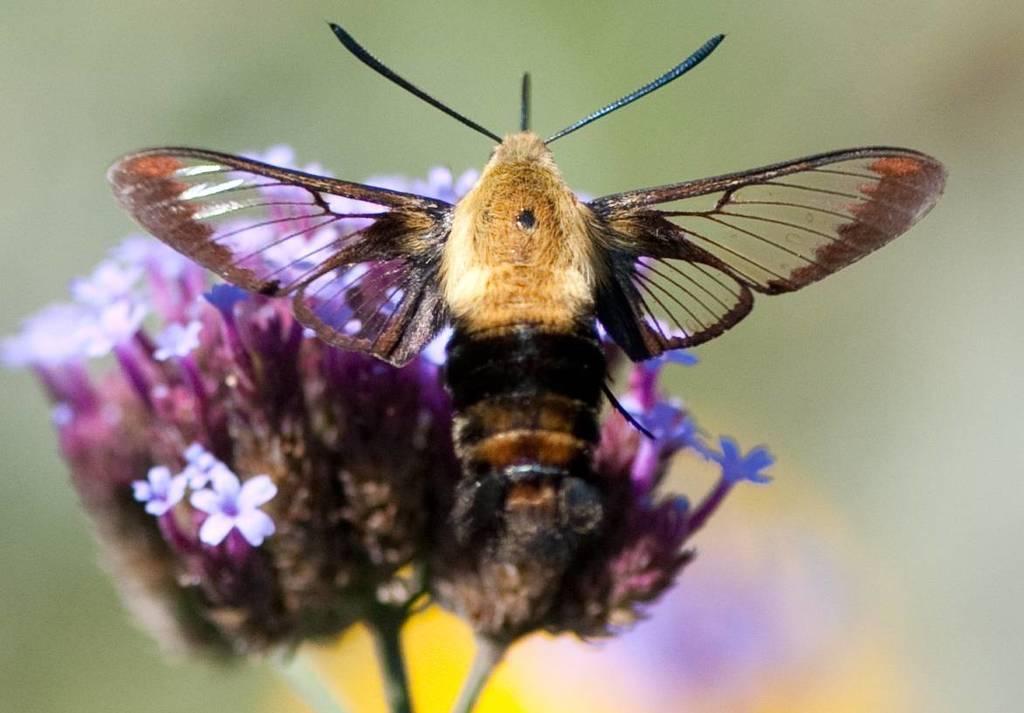Please provide a concise description of this image. In this image we can see an insect and also the flowers. The background is blurred. 